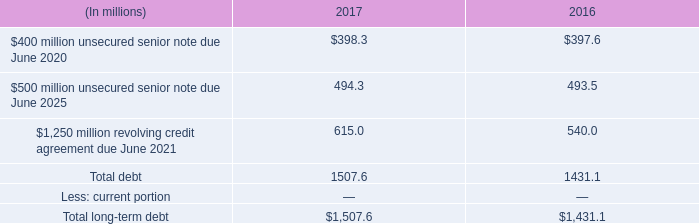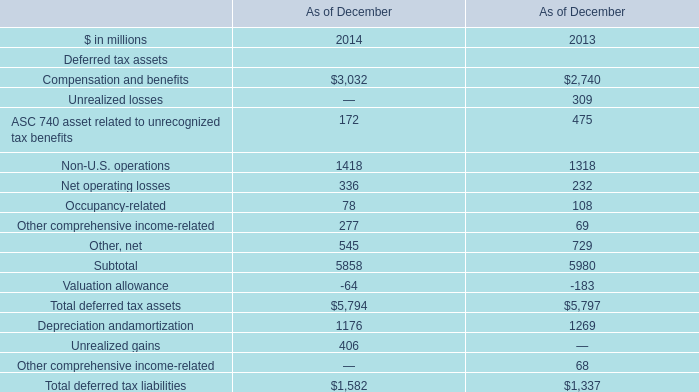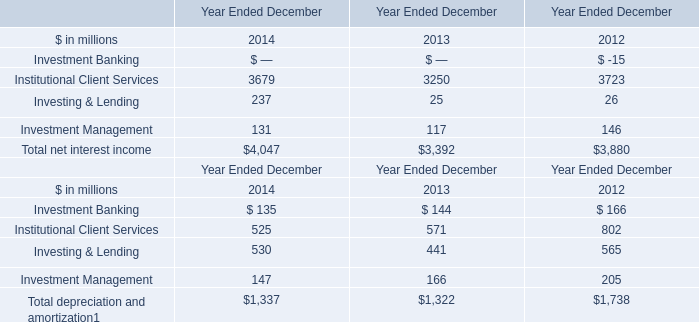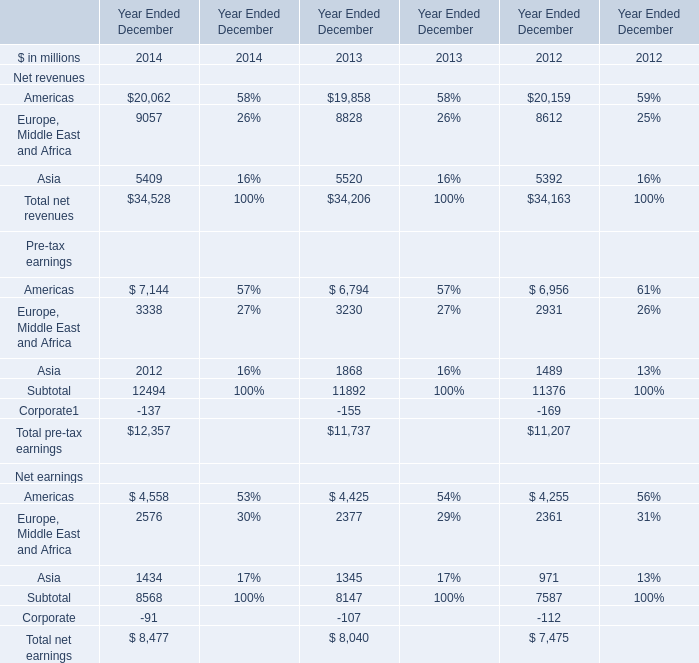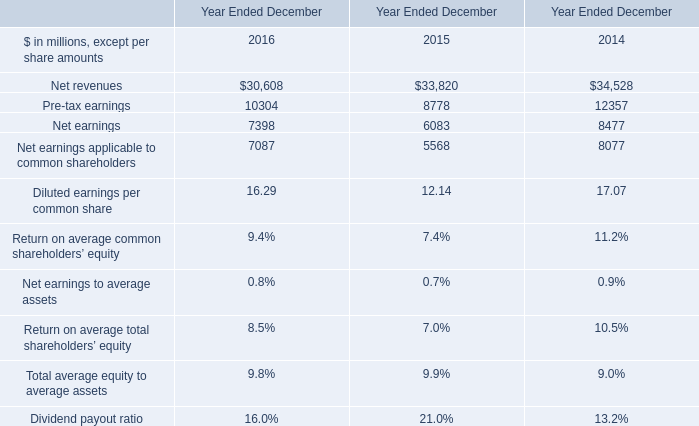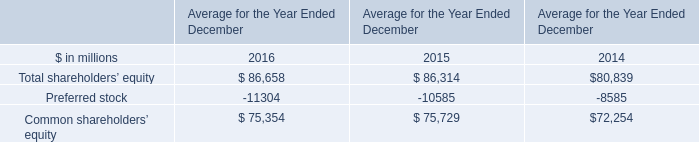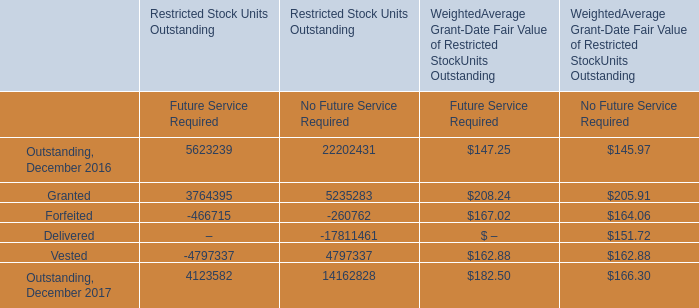What is the difference between 2013 and 2014 's highest element? (in million) 
Computations: (34528 - 34206)
Answer: 322.0. 